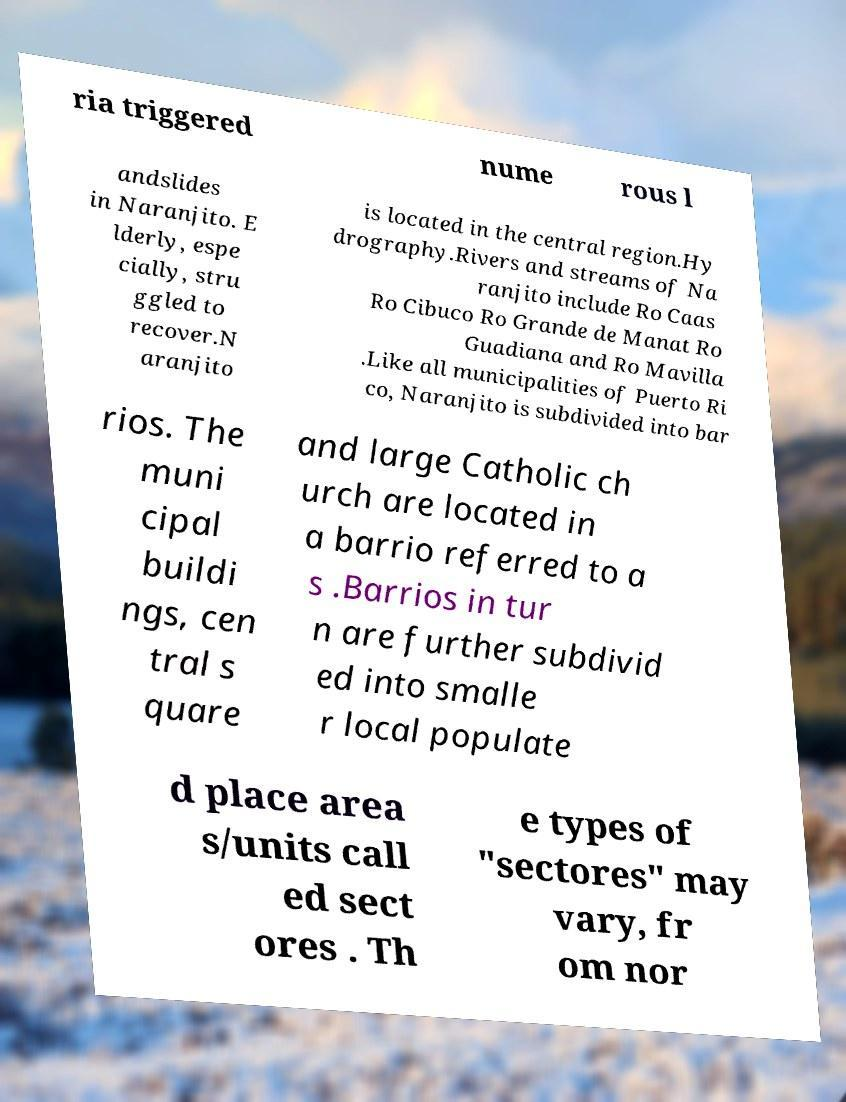Could you extract and type out the text from this image? ria triggered nume rous l andslides in Naranjito. E lderly, espe cially, stru ggled to recover.N aranjito is located in the central region.Hy drography.Rivers and streams of Na ranjito include Ro Caas Ro Cibuco Ro Grande de Manat Ro Guadiana and Ro Mavilla .Like all municipalities of Puerto Ri co, Naranjito is subdivided into bar rios. The muni cipal buildi ngs, cen tral s quare and large Catholic ch urch are located in a barrio referred to a s .Barrios in tur n are further subdivid ed into smalle r local populate d place area s/units call ed sect ores . Th e types of "sectores" may vary, fr om nor 